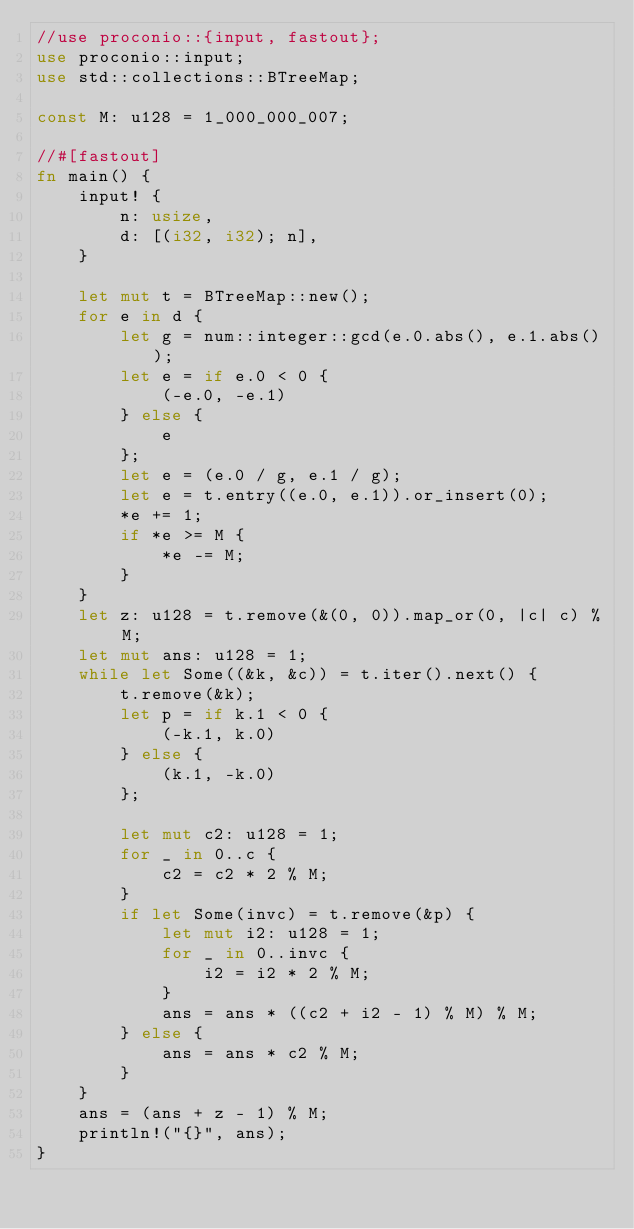Convert code to text. <code><loc_0><loc_0><loc_500><loc_500><_Rust_>//use proconio::{input, fastout};
use proconio::input;
use std::collections::BTreeMap;

const M: u128 = 1_000_000_007;

//#[fastout]
fn main() {
    input! {
        n: usize,
        d: [(i32, i32); n],
    }

    let mut t = BTreeMap::new();
    for e in d {
        let g = num::integer::gcd(e.0.abs(), e.1.abs());
        let e = if e.0 < 0 {
            (-e.0, -e.1)
        } else {
            e
        };
        let e = (e.0 / g, e.1 / g);
        let e = t.entry((e.0, e.1)).or_insert(0);
        *e += 1;
        if *e >= M {
            *e -= M;
        }
    }
    let z: u128 = t.remove(&(0, 0)).map_or(0, |c| c) % M;
    let mut ans: u128 = 1;
    while let Some((&k, &c)) = t.iter().next() {
        t.remove(&k);
        let p = if k.1 < 0 {
            (-k.1, k.0)
        } else {
            (k.1, -k.0)
        };

        let mut c2: u128 = 1;
        for _ in 0..c {
            c2 = c2 * 2 % M;
        }
        if let Some(invc) = t.remove(&p) {
            let mut i2: u128 = 1;
            for _ in 0..invc {
                i2 = i2 * 2 % M;
            }
            ans = ans * ((c2 + i2 - 1) % M) % M;
        } else {
            ans = ans * c2 % M;
        }
    }
    ans = (ans + z - 1) % M;
    println!("{}", ans);
}
</code> 